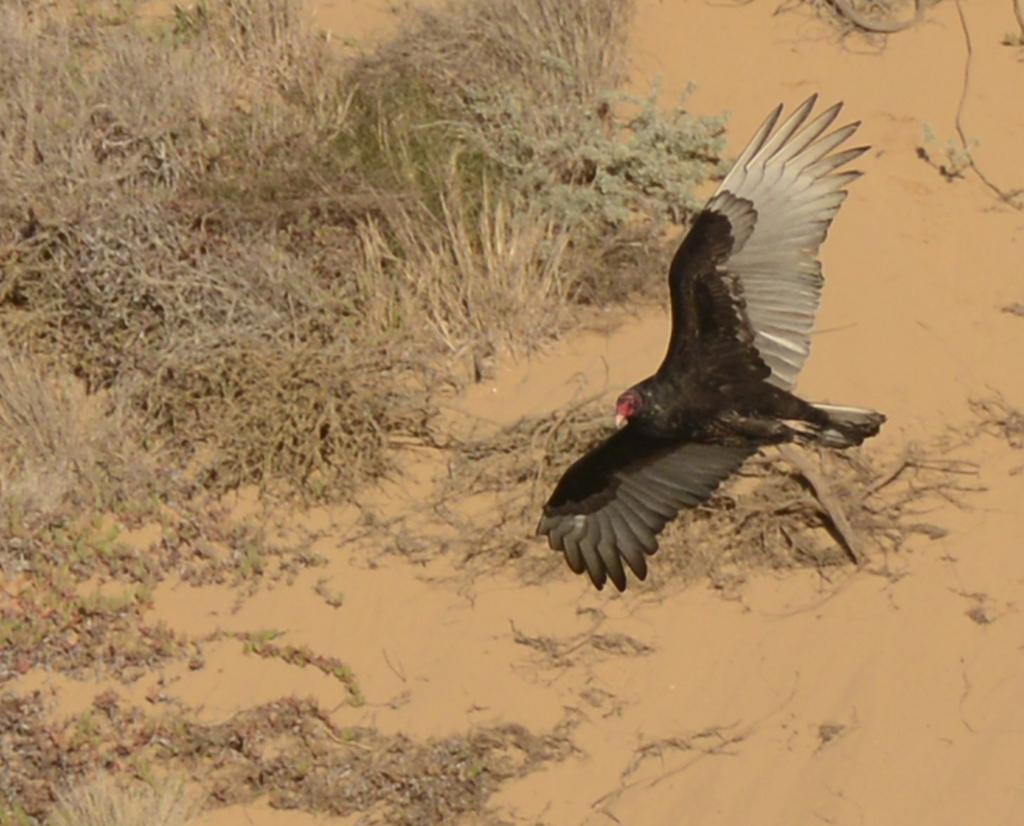What is flying in the air in the image? There is a bird in the air in the image. What type of living organisms can be seen in the image? The image contains a bird and plants. What type of curtain is hanging in the image? There is no curtain present in the image. What substance is the bird made of in the image? The bird is a living organism made of flesh, bones, and feathers, not a substance. 